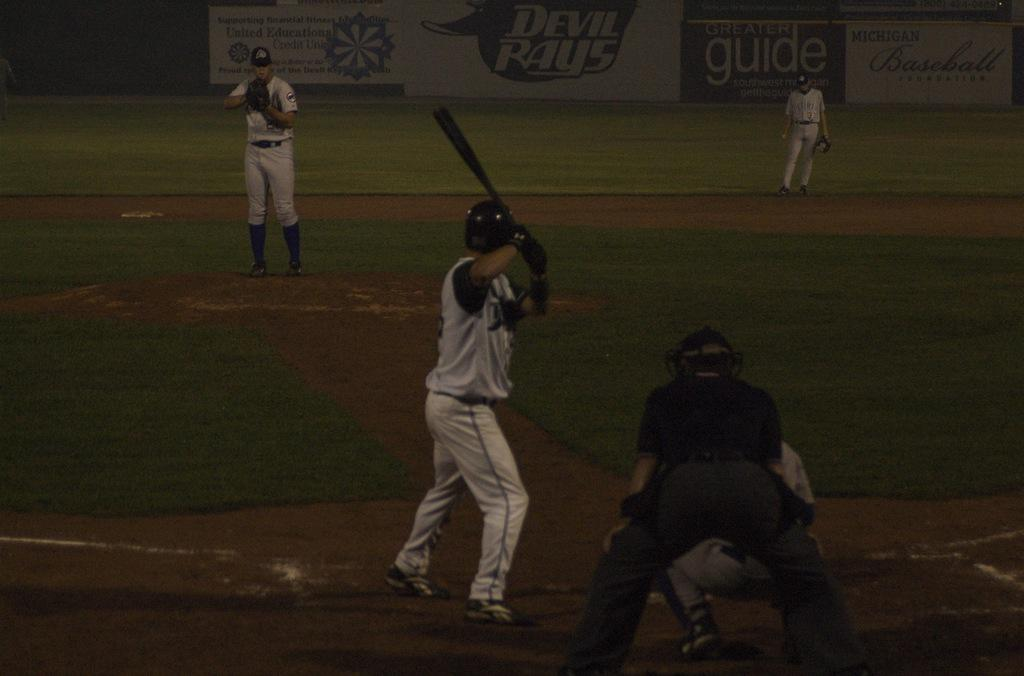What sport are the people playing in the image? The people are playing baseball in the image. What type of surface are they playing on? There is grass in the image, which suggests they are playing on a grassy field. What can be seen in the background of the image? There are banners with text in the background of the image. What type of regret can be seen on the faces of the men in the image? There is no indication of regret on the faces of the people in the image, as they are playing baseball and appear to be enjoying themselves. 